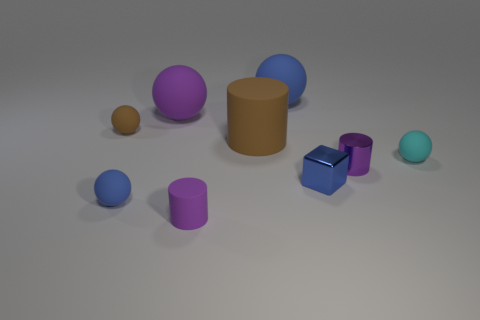There is a small purple object that is in front of the purple metallic cylinder; are there any shiny cubes that are to the left of it?
Ensure brevity in your answer.  No. Is the number of tiny cyan rubber spheres that are left of the large blue object greater than the number of big brown matte cylinders to the left of the purple matte sphere?
Provide a succinct answer. No. What material is the small ball that is the same color as the small block?
Provide a succinct answer. Rubber. How many large spheres have the same color as the tiny shiny cylinder?
Your answer should be very brief. 1. There is a tiny object behind the cyan sphere; is it the same color as the tiny rubber sphere in front of the blue cube?
Your response must be concise. No. Are there any small blue spheres behind the small blue metallic block?
Provide a short and direct response. No. What is the large blue object made of?
Ensure brevity in your answer.  Rubber. There is a purple object that is right of the big blue object; what shape is it?
Give a very brief answer. Cylinder. The object that is the same color as the large cylinder is what size?
Provide a short and direct response. Small. Is there a brown matte cylinder of the same size as the brown ball?
Your response must be concise. No. 